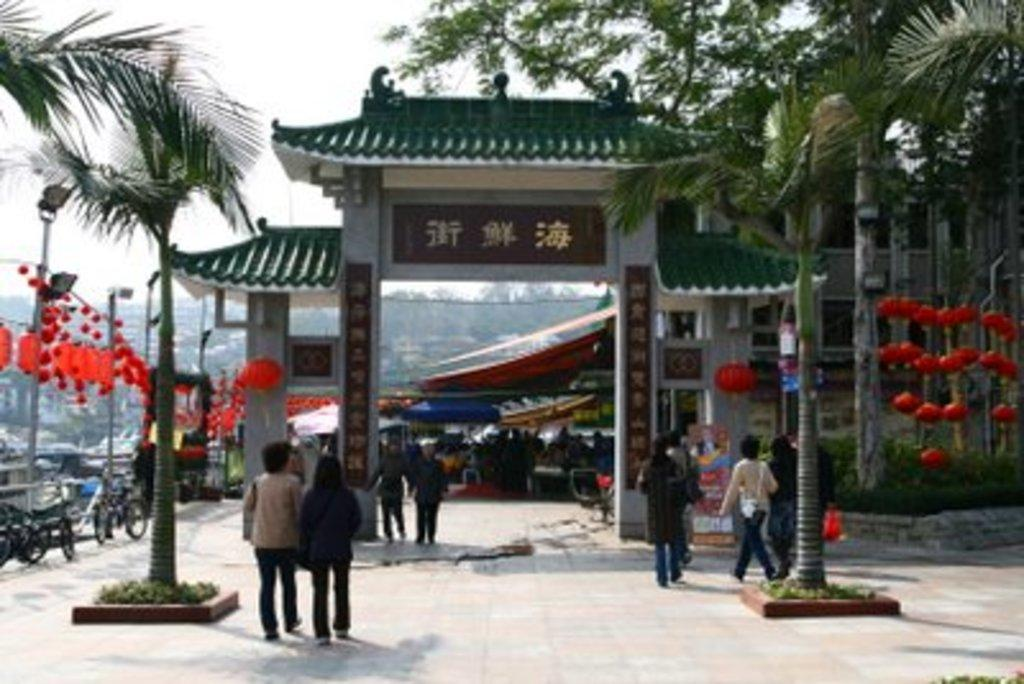How many people are in the image? There is a group of people in the image, but the exact number cannot be determined without more information. What else can be seen in the image besides the group of people? There are vehicles and trees visible in the image. What is visible in the background of the image? The sky is visible in the image. Where is the map located in the image? There is no map present in the image. What type of lip can be seen on the vehicles in the image? There are no lips visible in the image, as lips are a characteristic of living beings and not vehicles. 